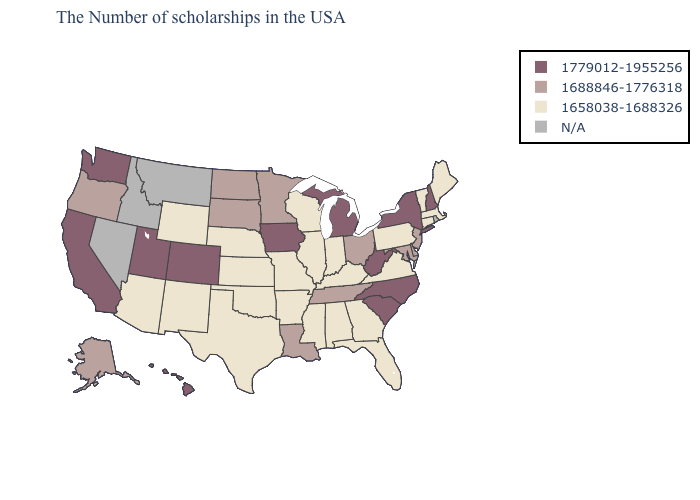What is the highest value in the South ?
Concise answer only. 1779012-1955256. Among the states that border Idaho , which have the lowest value?
Write a very short answer. Wyoming. Name the states that have a value in the range 1688846-1776318?
Concise answer only. New Jersey, Delaware, Maryland, Ohio, Tennessee, Louisiana, Minnesota, South Dakota, North Dakota, Oregon, Alaska. What is the highest value in the South ?
Short answer required. 1779012-1955256. Does Indiana have the highest value in the MidWest?
Quick response, please. No. What is the value of Florida?
Answer briefly. 1658038-1688326. Is the legend a continuous bar?
Write a very short answer. No. Name the states that have a value in the range N/A?
Concise answer only. Rhode Island, Montana, Idaho, Nevada. Among the states that border Missouri , does Oklahoma have the lowest value?
Quick response, please. Yes. Among the states that border Wyoming , which have the lowest value?
Answer briefly. Nebraska. Among the states that border Ohio , does West Virginia have the lowest value?
Write a very short answer. No. Does the map have missing data?
Be succinct. Yes. Does the first symbol in the legend represent the smallest category?
Concise answer only. No. 